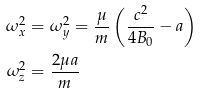<formula> <loc_0><loc_0><loc_500><loc_500>\omega _ { x } ^ { 2 } & = \omega _ { y } ^ { 2 } = \frac { \mu } { m } \left ( \frac { c ^ { 2 } } { 4 B _ { 0 } } - a \right ) \\ \omega _ { z } ^ { 2 } & = \frac { 2 \mu a } { m }</formula> 